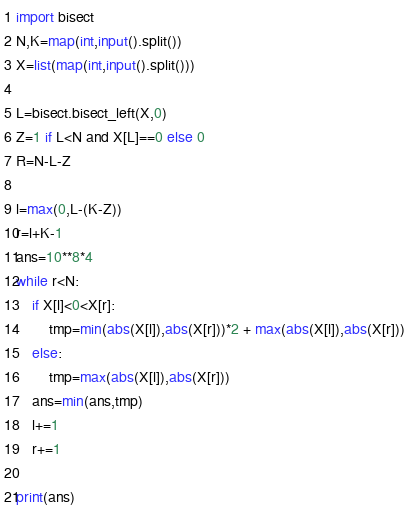Convert code to text. <code><loc_0><loc_0><loc_500><loc_500><_Python_>import bisect
N,K=map(int,input().split())
X=list(map(int,input().split()))

L=bisect.bisect_left(X,0)
Z=1 if L<N and X[L]==0 else 0
R=N-L-Z

l=max(0,L-(K-Z))
r=l+K-1
ans=10**8*4
while r<N:
    if X[l]<0<X[r]:
        tmp=min(abs(X[l]),abs(X[r]))*2 + max(abs(X[l]),abs(X[r]))
    else:
        tmp=max(abs(X[l]),abs(X[r]))
    ans=min(ans,tmp)
    l+=1
    r+=1

print(ans)
</code> 